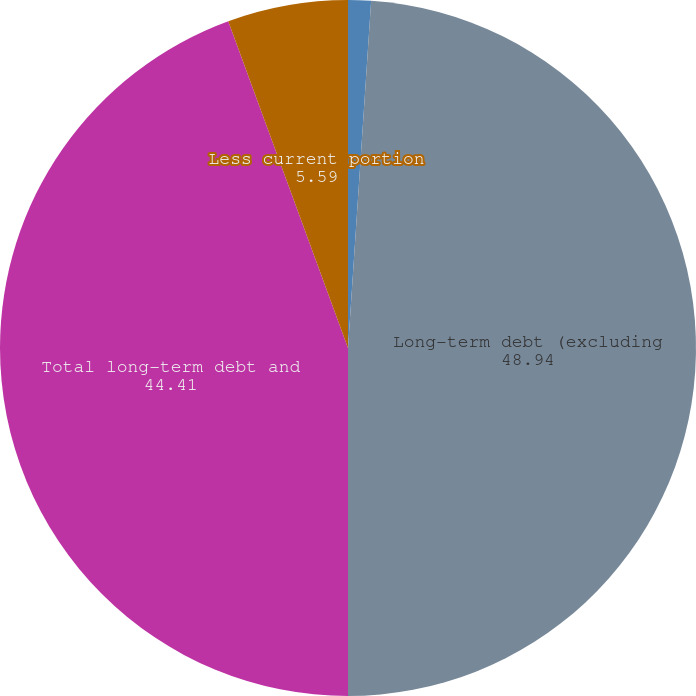Convert chart to OTSL. <chart><loc_0><loc_0><loc_500><loc_500><pie_chart><fcel>Capital leases<fcel>Long-term debt (excluding<fcel>Total long-term debt and<fcel>Less current portion<nl><fcel>1.06%<fcel>48.94%<fcel>44.41%<fcel>5.59%<nl></chart> 